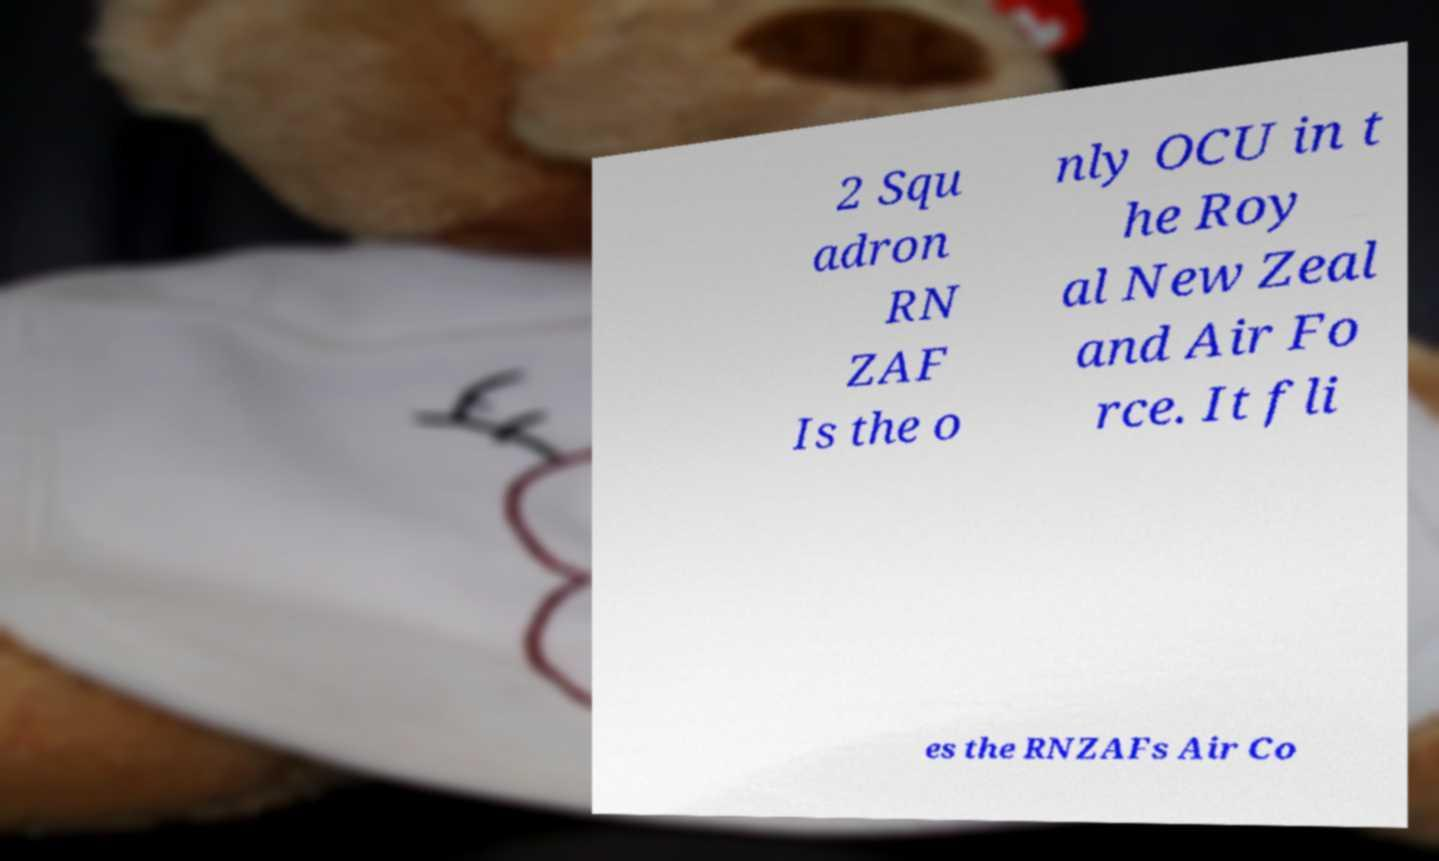Could you assist in decoding the text presented in this image and type it out clearly? 2 Squ adron RN ZAF Is the o nly OCU in t he Roy al New Zeal and Air Fo rce. It fli es the RNZAFs Air Co 